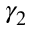<formula> <loc_0><loc_0><loc_500><loc_500>\gamma _ { 2 }</formula> 